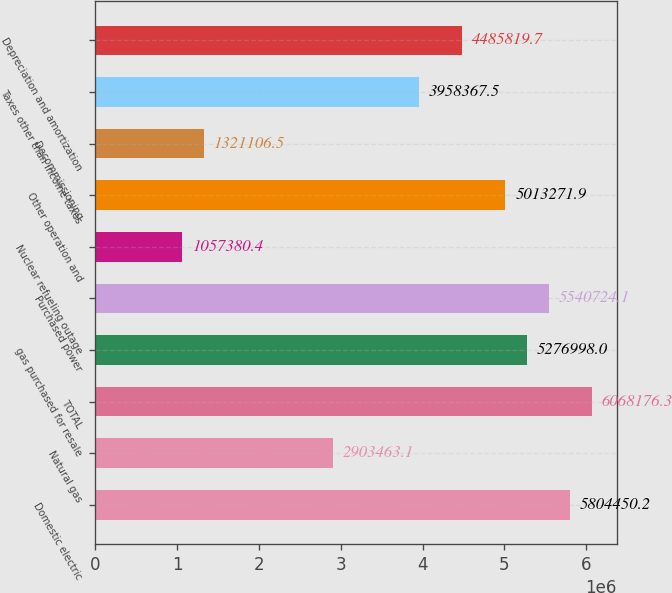Convert chart. <chart><loc_0><loc_0><loc_500><loc_500><bar_chart><fcel>Domestic electric<fcel>Natural gas<fcel>TOTAL<fcel>gas purchased for resale<fcel>Purchased power<fcel>Nuclear refueling outage<fcel>Other operation and<fcel>Decommissioning<fcel>Taxes other than income taxes<fcel>Depreciation and amortization<nl><fcel>5.80445e+06<fcel>2.90346e+06<fcel>6.06818e+06<fcel>5.277e+06<fcel>5.54072e+06<fcel>1.05738e+06<fcel>5.01327e+06<fcel>1.32111e+06<fcel>3.95837e+06<fcel>4.48582e+06<nl></chart> 